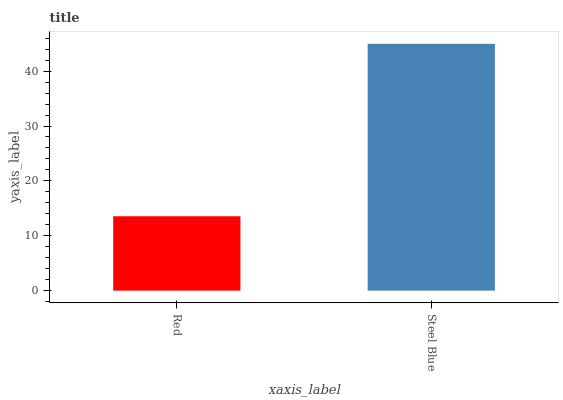Is Red the minimum?
Answer yes or no. Yes. Is Steel Blue the maximum?
Answer yes or no. Yes. Is Steel Blue the minimum?
Answer yes or no. No. Is Steel Blue greater than Red?
Answer yes or no. Yes. Is Red less than Steel Blue?
Answer yes or no. Yes. Is Red greater than Steel Blue?
Answer yes or no. No. Is Steel Blue less than Red?
Answer yes or no. No. Is Steel Blue the high median?
Answer yes or no. Yes. Is Red the low median?
Answer yes or no. Yes. Is Red the high median?
Answer yes or no. No. Is Steel Blue the low median?
Answer yes or no. No. 